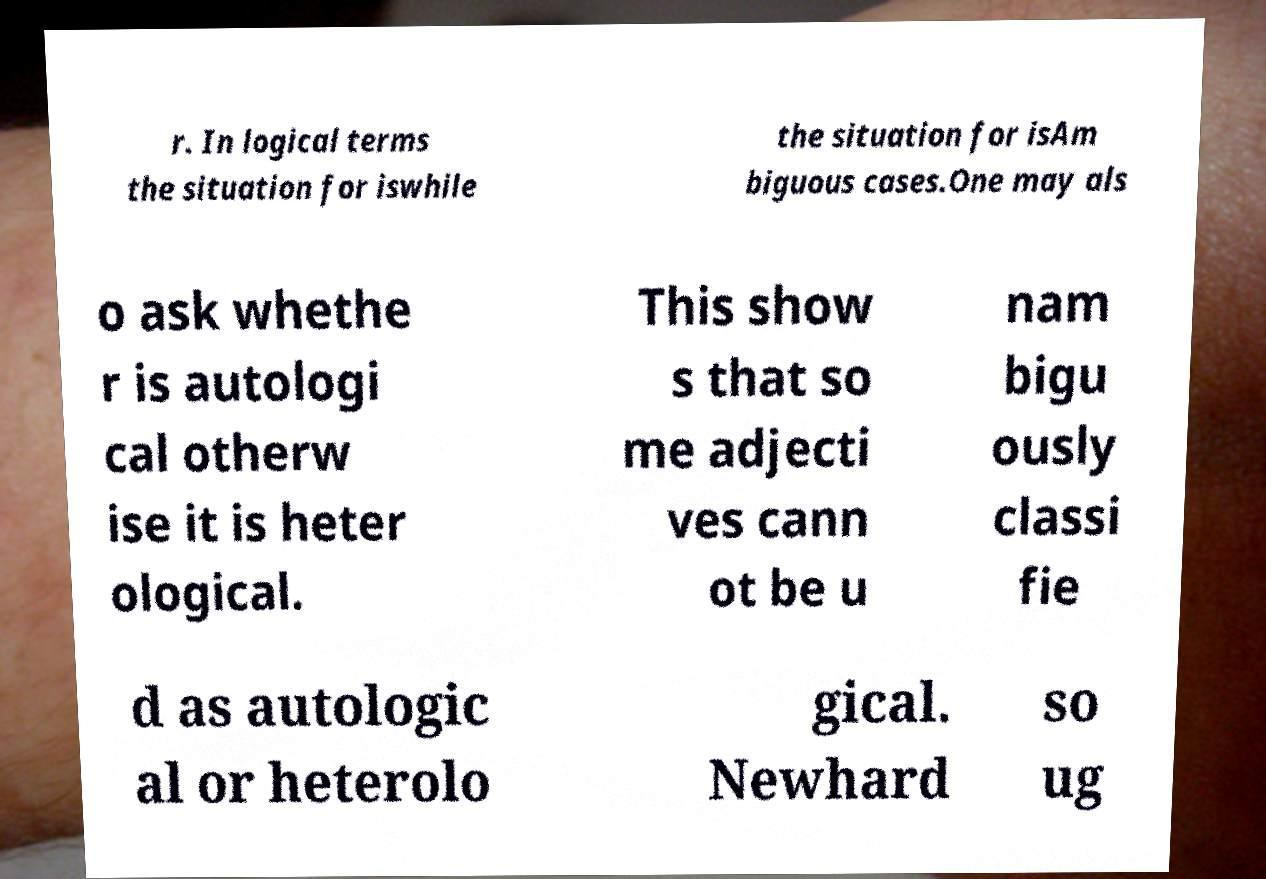I need the written content from this picture converted into text. Can you do that? r. In logical terms the situation for iswhile the situation for isAm biguous cases.One may als o ask whethe r is autologi cal otherw ise it is heter ological. This show s that so me adjecti ves cann ot be u nam bigu ously classi fie d as autologic al or heterolo gical. Newhard so ug 